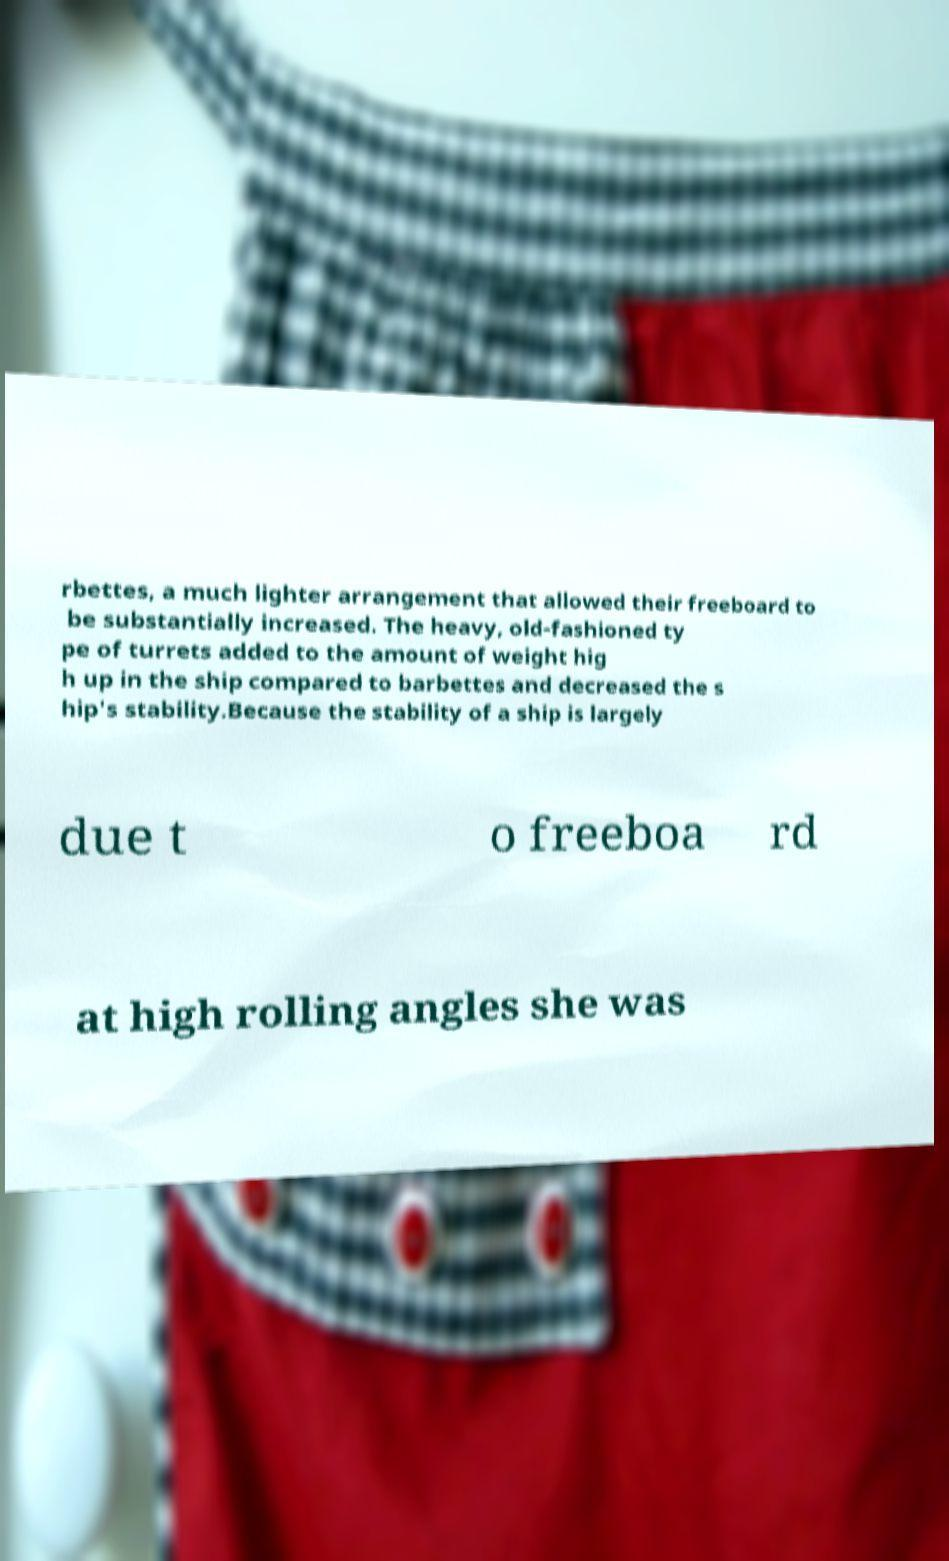Please identify and transcribe the text found in this image. rbettes, a much lighter arrangement that allowed their freeboard to be substantially increased. The heavy, old-fashioned ty pe of turrets added to the amount of weight hig h up in the ship compared to barbettes and decreased the s hip's stability.Because the stability of a ship is largely due t o freeboa rd at high rolling angles she was 